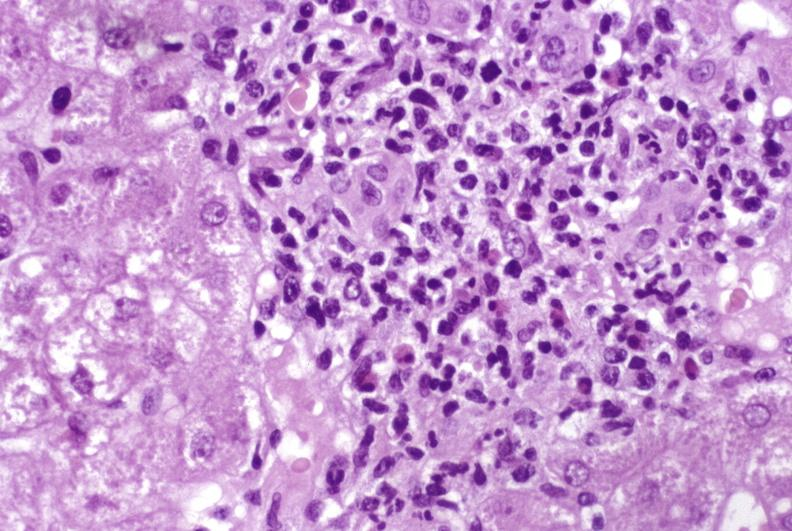does this image show moderate acute rejection?
Answer the question using a single word or phrase. Yes 